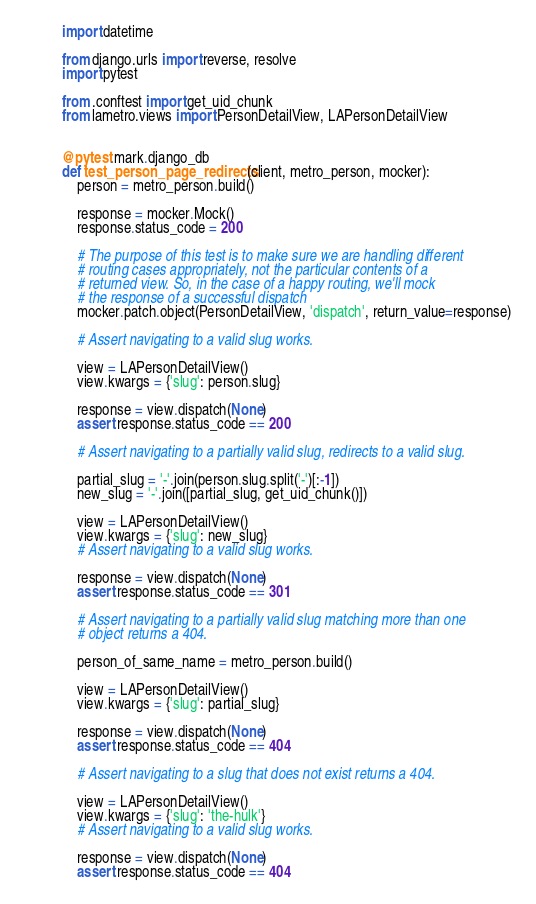Convert code to text. <code><loc_0><loc_0><loc_500><loc_500><_Python_>import datetime

from django.urls import reverse, resolve
import pytest

from .conftest import get_uid_chunk
from lametro.views import PersonDetailView, LAPersonDetailView


@pytest.mark.django_db
def test_person_page_redirects(client, metro_person, mocker):
    person = metro_person.build()

    response = mocker.Mock()
    response.status_code = 200

    # The purpose of this test is to make sure we are handling different
    # routing cases appropriately, not the particular contents of a
    # returned view. So, in the case of a happy routing, we'll mock
    # the response of a successful dispatch
    mocker.patch.object(PersonDetailView, 'dispatch', return_value=response)

    # Assert navigating to a valid slug works.

    view = LAPersonDetailView()
    view.kwargs = {'slug': person.slug}

    response = view.dispatch(None)
    assert response.status_code == 200

    # Assert navigating to a partially valid slug, redirects to a valid slug.

    partial_slug = '-'.join(person.slug.split('-')[:-1])
    new_slug = '-'.join([partial_slug, get_uid_chunk()])

    view = LAPersonDetailView()
    view.kwargs = {'slug': new_slug}
    # Assert navigating to a valid slug works.

    response = view.dispatch(None)
    assert response.status_code == 301

    # Assert navigating to a partially valid slug matching more than one
    # object returns a 404.

    person_of_same_name = metro_person.build()

    view = LAPersonDetailView()
    view.kwargs = {'slug': partial_slug}

    response = view.dispatch(None)
    assert response.status_code == 404

    # Assert navigating to a slug that does not exist returns a 404.

    view = LAPersonDetailView()
    view.kwargs = {'slug': 'the-hulk'}
    # Assert navigating to a valid slug works.

    response = view.dispatch(None)
    assert response.status_code == 404
</code> 